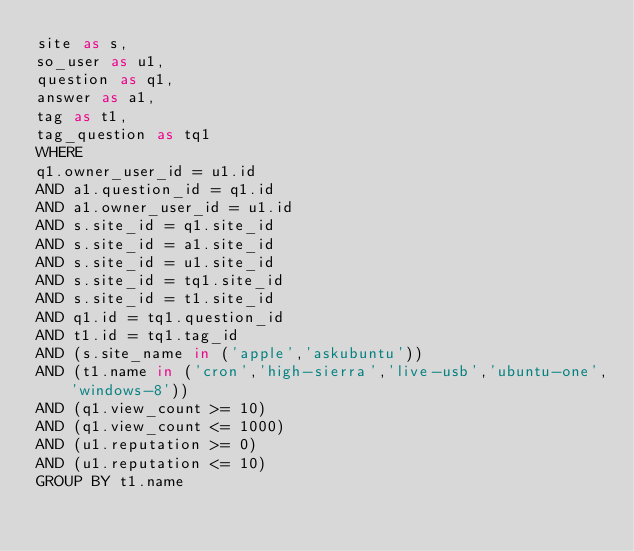<code> <loc_0><loc_0><loc_500><loc_500><_SQL_>site as s,
so_user as u1,
question as q1,
answer as a1,
tag as t1,
tag_question as tq1
WHERE
q1.owner_user_id = u1.id
AND a1.question_id = q1.id
AND a1.owner_user_id = u1.id
AND s.site_id = q1.site_id
AND s.site_id = a1.site_id
AND s.site_id = u1.site_id
AND s.site_id = tq1.site_id
AND s.site_id = t1.site_id
AND q1.id = tq1.question_id
AND t1.id = tq1.tag_id
AND (s.site_name in ('apple','askubuntu'))
AND (t1.name in ('cron','high-sierra','live-usb','ubuntu-one','windows-8'))
AND (q1.view_count >= 10)
AND (q1.view_count <= 1000)
AND (u1.reputation >= 0)
AND (u1.reputation <= 10)
GROUP BY t1.name</code> 